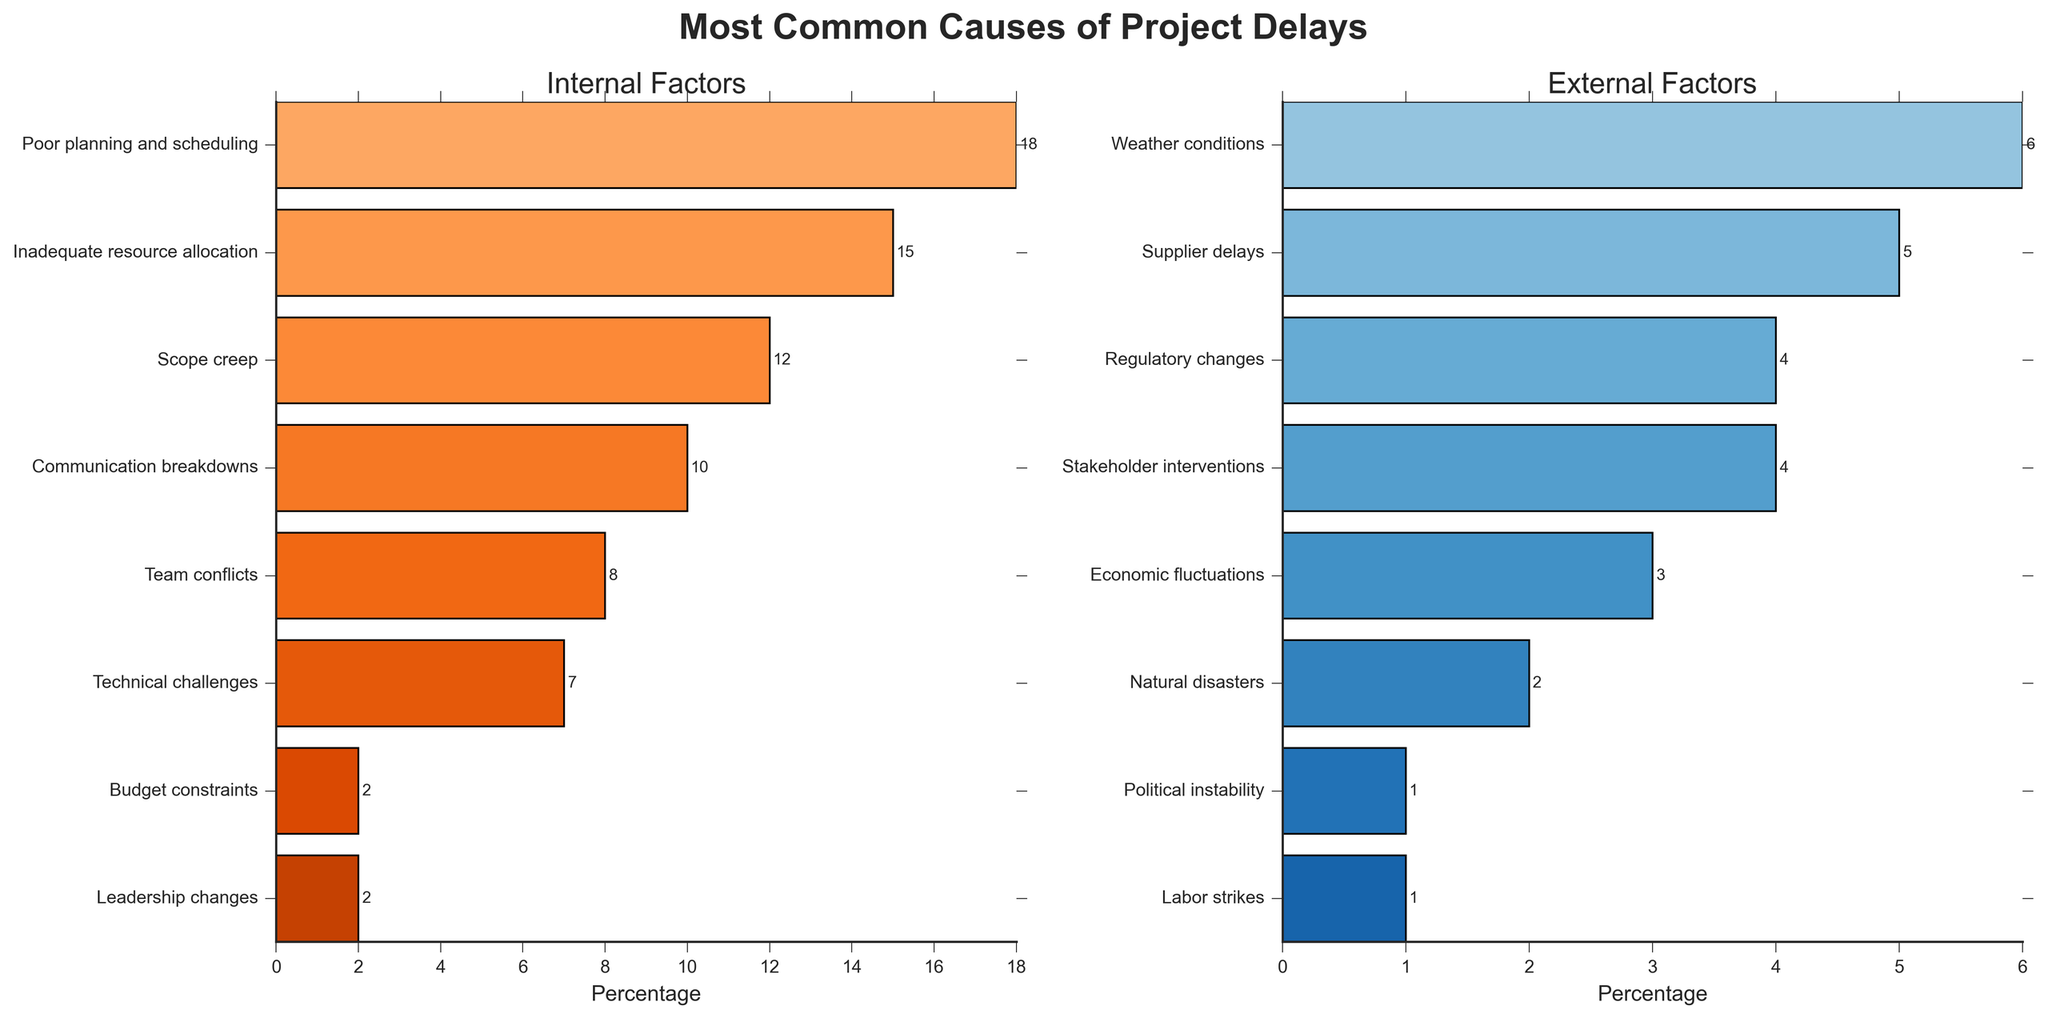Which internal factor causes the most project delays? The bar representing "Poor planning and scheduling" is the longest among the internal factors, indicating the highest percentage.
Answer: Poor planning and scheduling What's the combined percentage of delays caused by communication breakdowns and team conflicts? The bar for "Communication breakdowns" is 10% and for "Team conflicts" is 8%. Adding these percentages together gives 10% + 8% = 18%.
Answer: 18% Which external factor accounts for the lowest percentage of project delays? The shortest bars among the external factors are for "Political instability" and "Labor strikes", both at 1%. Therefore, these two factors tie for the lowest.
Answer: Political instability and labor strikes Is the percentage of delays due to supplier delays greater than that due to weather conditions? The bar for "Supplier delays" stands at 5%, while the bar for "Weather conditions" is at 6%, meaning the percentage for supplier delays is less.
Answer: No How much greater is the percentage of project delays caused by poor planning and scheduling compared to regulatory changes? The bar for "Poor planning and scheduling" is 18%, and for "Regulatory changes" is 4%. The difference is 18% - 4% = 14%.
Answer: 14% What percentage of delays do technical challenges and budget constraints account for together? Technical challenges represent 7% and budget constraints 2%. Adding them gives 7% + 2% = 9%.
Answer: 9% Which factor among the external causes has the highest percentage of project delays? The longest bar among the external factors is for "Weather conditions", which is at 6%.
Answer: Weather conditions Is the total percentage of delays caused by internal factors greater than those caused by external factors? Summing internal factors (18% + 15% + 12% + 10% + 8% + 7% + 2% + 2%) equals 74%; summing external factors (6% + 5% + 4% + 4% + 3% + 2% + 1% + 1%) equals 26%. 74% is greater than 26%.
Answer: Yes Which internal factor has the smallest impact on project delays? The shortest bars among the internal factors are for "Budget constraints" and "Leadership changes", both at 2%. These two factors tie for the smallest impact.
Answer: Budget constraints and leadership changes What is the average percentage of delays caused by external factors? Summing the percentages for external factors gives 6% + 5% + 4% + 4% + 3% + 2% + 1% + 1% = 26%. There are 8 external factors, so the average is 26% / 8 = 3.25%.
Answer: 3.25% 